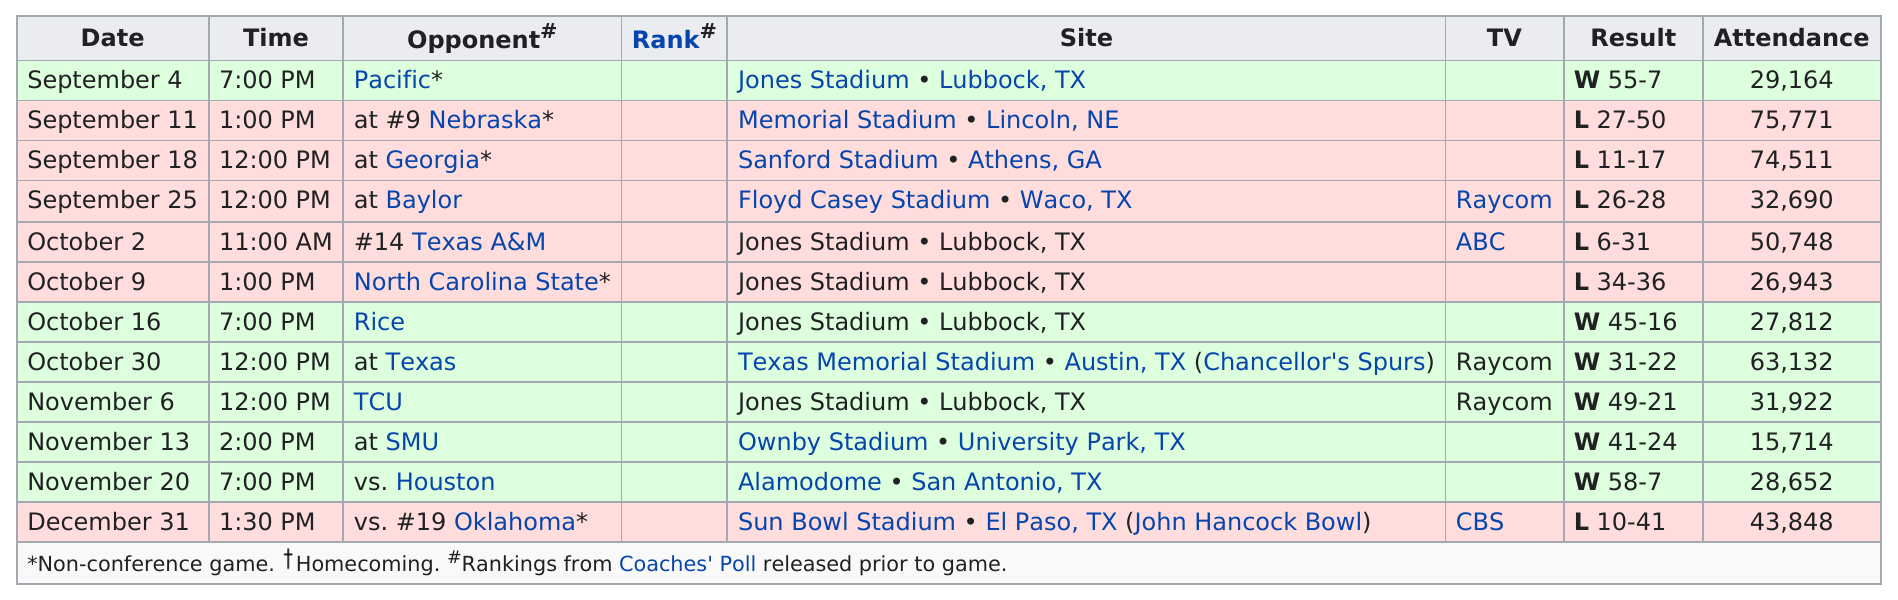Identify some key points in this picture. During the period of September 11th to October 9th, Texas Tech experienced five consecutive losses. The 1993 Texas Tech football team played a total of 8 games, with 4 of those games taking place in either September or October. The Texas Tech team faced their last opponent in 1993, which was Oklahoma. In the regular season of 1993, Texas Tech amassed a total of 6 victories. The Texas Tech Red Raiders won 6 games. 